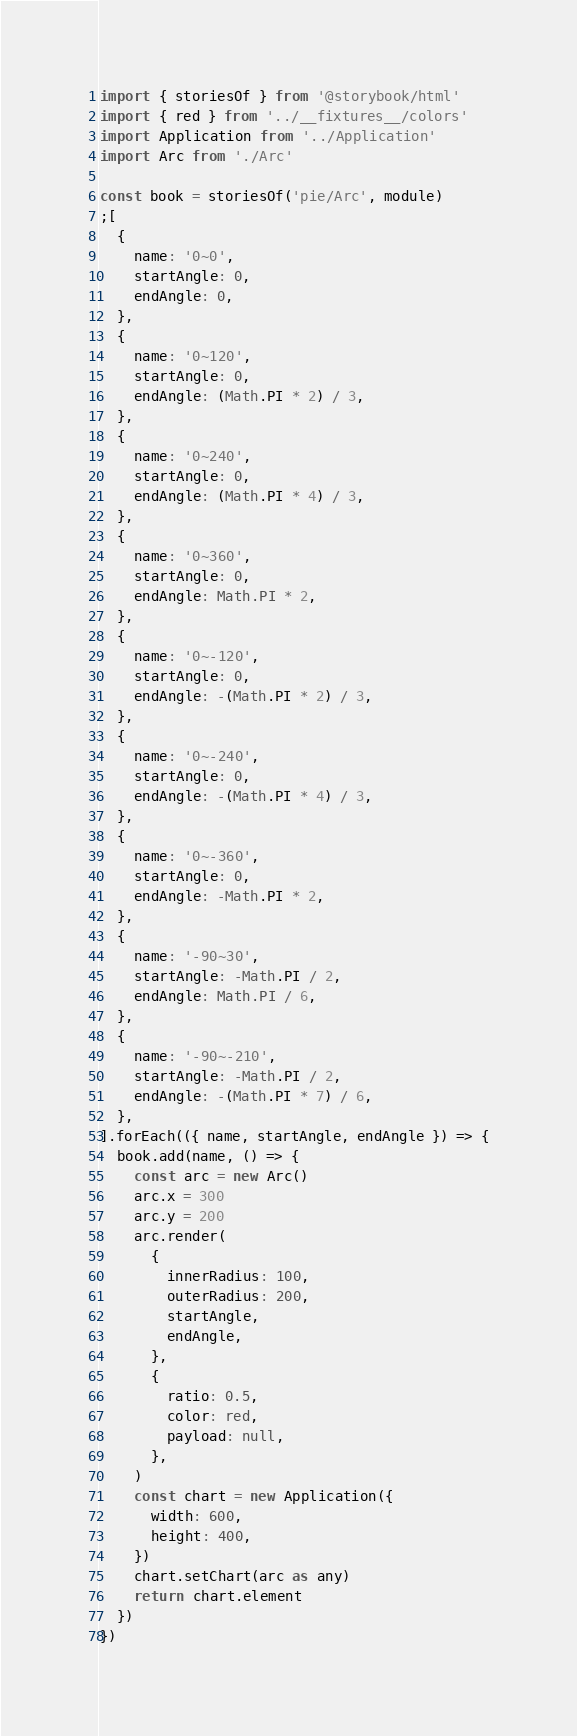Convert code to text. <code><loc_0><loc_0><loc_500><loc_500><_TypeScript_>import { storiesOf } from '@storybook/html'
import { red } from '../__fixtures__/colors'
import Application from '../Application'
import Arc from './Arc'

const book = storiesOf('pie/Arc', module)
;[
  {
    name: '0~0',
    startAngle: 0,
    endAngle: 0,
  },
  {
    name: '0~120',
    startAngle: 0,
    endAngle: (Math.PI * 2) / 3,
  },
  {
    name: '0~240',
    startAngle: 0,
    endAngle: (Math.PI * 4) / 3,
  },
  {
    name: '0~360',
    startAngle: 0,
    endAngle: Math.PI * 2,
  },
  {
    name: '0~-120',
    startAngle: 0,
    endAngle: -(Math.PI * 2) / 3,
  },
  {
    name: '0~-240',
    startAngle: 0,
    endAngle: -(Math.PI * 4) / 3,
  },
  {
    name: '0~-360',
    startAngle: 0,
    endAngle: -Math.PI * 2,
  },
  {
    name: '-90~30',
    startAngle: -Math.PI / 2,
    endAngle: Math.PI / 6,
  },
  {
    name: '-90~-210',
    startAngle: -Math.PI / 2,
    endAngle: -(Math.PI * 7) / 6,
  },
].forEach(({ name, startAngle, endAngle }) => {
  book.add(name, () => {
    const arc = new Arc()
    arc.x = 300
    arc.y = 200
    arc.render(
      {
        innerRadius: 100,
        outerRadius: 200,
        startAngle,
        endAngle,
      },
      {
        ratio: 0.5,
        color: red,
        payload: null,
      },
    )
    const chart = new Application({
      width: 600,
      height: 400,
    })
    chart.setChart(arc as any)
    return chart.element
  })
})
</code> 